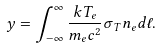<formula> <loc_0><loc_0><loc_500><loc_500>y = \int _ { - \infty } ^ { \infty } \frac { k T _ { e } } { m _ { e } c ^ { 2 } } \sigma _ { T } n _ { e } d \ell .</formula> 